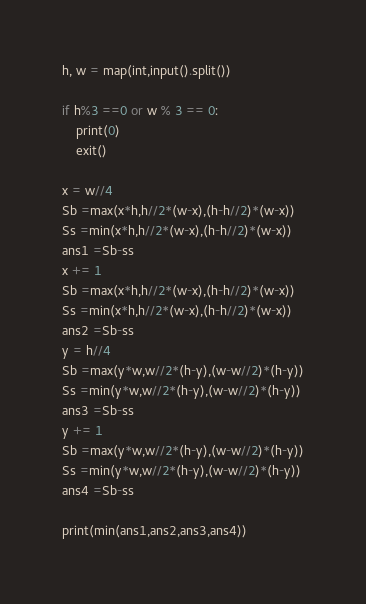Convert code to text. <code><loc_0><loc_0><loc_500><loc_500><_Python_>h, w = map(int,input().split())

if h%3 ==0 or w % 3 == 0:
	print(0)
	exit()

x = w//4
Sb =max(x*h,h//2*(w-x),(h-h//2)*(w-x))
Ss =min(x*h,h//2*(w-x),(h-h//2)*(w-x))
ans1 =Sb-ss
x += 1
Sb =max(x*h,h//2*(w-x),(h-h//2)*(w-x))
Ss =min(x*h,h//2*(w-x),(h-h//2)*(w-x))
ans2 =Sb-ss
y = h//4
Sb =max(y*w,w//2*(h-y),(w-w//2)*(h-y))
Ss =min(y*w,w//2*(h-y),(w-w//2)*(h-y))
ans3 =Sb-ss
y += 1
Sb =max(y*w,w//2*(h-y),(w-w//2)*(h-y))
Ss =min(y*w,w//2*(h-y),(w-w//2)*(h-y))
ans4 =Sb-ss

print(min(ans1,ans2,ans3,ans4))</code> 